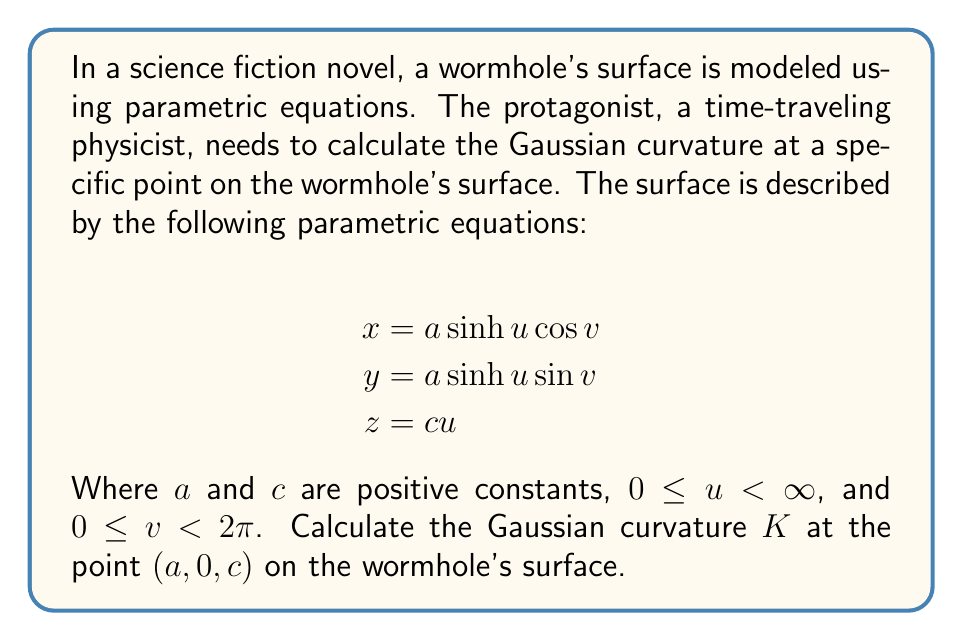Can you solve this math problem? To calculate the Gaussian curvature, we need to follow these steps:

1) First, we need to find the partial derivatives of x, y, and z with respect to u and v:

   $$x_u = a \cosh u \cos v, \quad x_v = -a \sinh u \sin v$$
   $$y_u = a \cosh u \sin v, \quad y_v = a \sinh u \cos v$$
   $$z_u = c, \quad z_v = 0$$

2) Now, we calculate the coefficients of the first fundamental form:

   $$E = x_u^2 + y_u^2 + z_u^2 = a^2 \cosh^2 u + c^2$$
   $$F = x_u x_v + y_u y_v + z_u z_v = 0$$
   $$G = x_v^2 + y_v^2 + z_v^2 = a^2 \sinh^2 u$$

3) Next, we calculate the second partial derivatives:

   $$x_{uu} = a \sinh u \cos v, \quad x_{uv} = -a \cosh u \sin v, \quad x_{vv} = -a \sinh u \cos v$$
   $$y_{uu} = a \sinh u \sin v, \quad y_{uv} = a \cosh u \cos v, \quad y_{vv} = -a \sinh u \sin v$$
   $$z_{uu} = z_{uv} = z_{vv} = 0$$

4) We can now calculate the coefficients of the second fundamental form:

   $$L = \frac{x_u (y_u z_{uu} - z_u y_{uu}) + y_u (z_u x_{uu} - x_u z_{uu}) + z_u (x_u y_{uu} - y_u x_{uu})}{\sqrt{EG-F^2}}$$
   $$M = \frac{x_u (y_v z_{uv} - z_v y_{uv}) + y_u (z_v x_{uv} - x_v z_{uv}) + z_u (x_v y_{uv} - y_v x_{uv})}{\sqrt{EG-F^2}}$$
   $$N = \frac{x_v (y_v z_{vv} - z_v y_{vv}) + y_v (z_v x_{vv} - x_v z_{vv}) + z_v (x_v y_{vv} - y_v x_{vv})}{\sqrt{EG-F^2}}$$

5) The Gaussian curvature is given by:

   $$K = \frac{LN - M^2}{EG - F^2}$$

6) At the point $(a, 0, c)$, we have $u = \sinh^{-1}(1)$ and $v = 0$. Substituting these values:

   $$E = a^2 \cosh^2 (\sinh^{-1}(1)) + c^2 = 2a^2 + c^2$$
   $$F = 0$$
   $$G = a^2$$

   $$L = -\frac{ac}{\sqrt{2a^2 + c^2}}$$
   $$M = 0$$
   $$N = -\frac{ac}{\sqrt{2a^2 + c^2}}$$

7) Finally, we can calculate the Gaussian curvature:

   $$K = \frac{(-\frac{ac}{\sqrt{2a^2 + c^2}})(-\frac{ac}{\sqrt{2a^2 + c^2}}) - 0^2}{(2a^2 + c^2)(a^2) - 0^2} = \frac{a^2c^2}{(2a^2 + c^2)^2a^2}$$
Answer: The Gaussian curvature at the point $(a, 0, c)$ on the wormhole's surface is:

$$K = \frac{c^2}{a^2(2a^2 + c^2)}$$ 